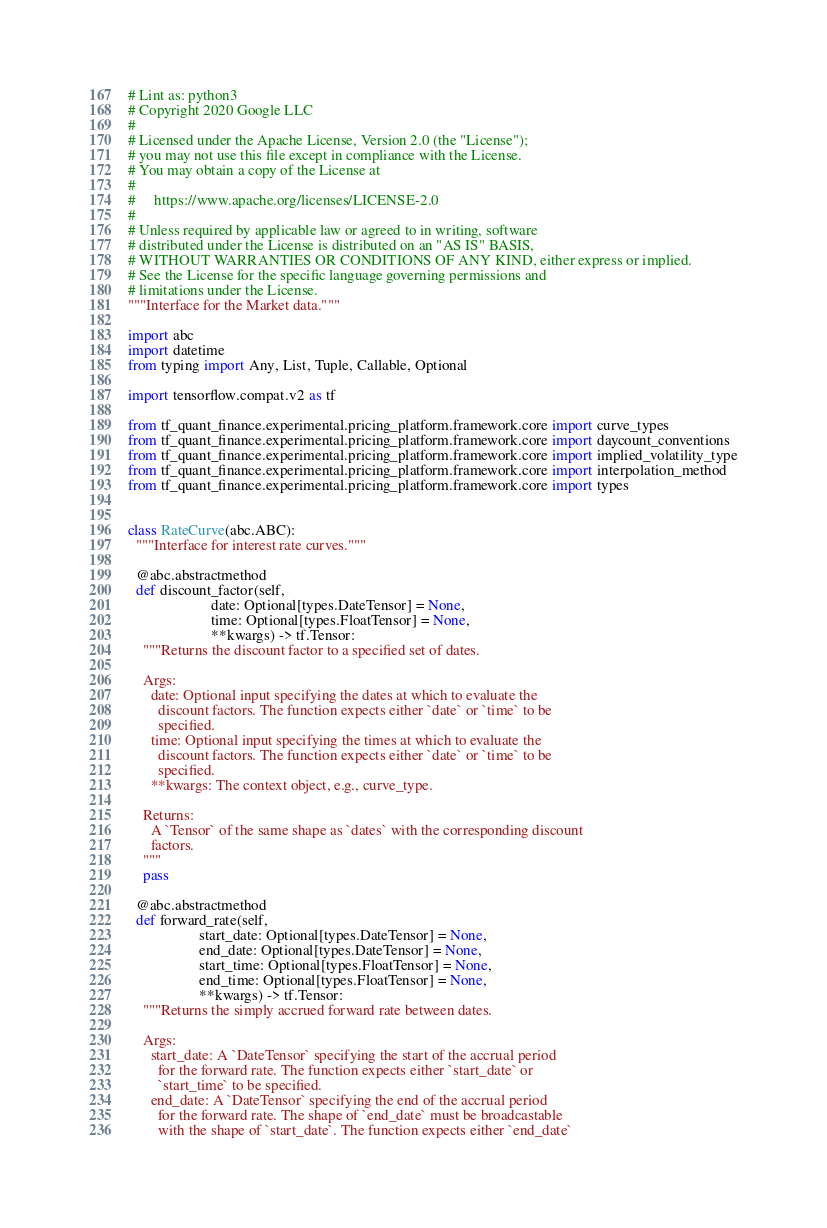Convert code to text. <code><loc_0><loc_0><loc_500><loc_500><_Python_># Lint as: python3
# Copyright 2020 Google LLC
#
# Licensed under the Apache License, Version 2.0 (the "License");
# you may not use this file except in compliance with the License.
# You may obtain a copy of the License at
#
#     https://www.apache.org/licenses/LICENSE-2.0
#
# Unless required by applicable law or agreed to in writing, software
# distributed under the License is distributed on an "AS IS" BASIS,
# WITHOUT WARRANTIES OR CONDITIONS OF ANY KIND, either express or implied.
# See the License for the specific language governing permissions and
# limitations under the License.
"""Interface for the Market data."""

import abc
import datetime
from typing import Any, List, Tuple, Callable, Optional

import tensorflow.compat.v2 as tf

from tf_quant_finance.experimental.pricing_platform.framework.core import curve_types
from tf_quant_finance.experimental.pricing_platform.framework.core import daycount_conventions
from tf_quant_finance.experimental.pricing_platform.framework.core import implied_volatility_type
from tf_quant_finance.experimental.pricing_platform.framework.core import interpolation_method
from tf_quant_finance.experimental.pricing_platform.framework.core import types


class RateCurve(abc.ABC):
  """Interface for interest rate curves."""

  @abc.abstractmethod
  def discount_factor(self,
                      date: Optional[types.DateTensor] = None,
                      time: Optional[types.FloatTensor] = None,
                      **kwargs) -> tf.Tensor:
    """Returns the discount factor to a specified set of dates.

    Args:
      date: Optional input specifying the dates at which to evaluate the
        discount factors. The function expects either `date` or `time` to be
        specified.
      time: Optional input specifying the times at which to evaluate the
        discount factors. The function expects either `date` or `time` to be
        specified.
      **kwargs: The context object, e.g., curve_type.

    Returns:
      A `Tensor` of the same shape as `dates` with the corresponding discount
      factors.
    """
    pass

  @abc.abstractmethod
  def forward_rate(self,
                   start_date: Optional[types.DateTensor] = None,
                   end_date: Optional[types.DateTensor] = None,
                   start_time: Optional[types.FloatTensor] = None,
                   end_time: Optional[types.FloatTensor] = None,
                   **kwargs) -> tf.Tensor:
    """Returns the simply accrued forward rate between dates.

    Args:
      start_date: A `DateTensor` specifying the start of the accrual period
        for the forward rate. The function expects either `start_date` or
        `start_time` to be specified.
      end_date: A `DateTensor` specifying the end of the accrual period
        for the forward rate. The shape of `end_date` must be broadcastable
        with the shape of `start_date`. The function expects either `end_date`</code> 